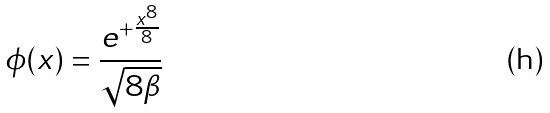<formula> <loc_0><loc_0><loc_500><loc_500>\phi ( x ) = \frac { e ^ { + \frac { x ^ { 8 } } { 8 } } } { \sqrt { 8 \beta } }</formula> 